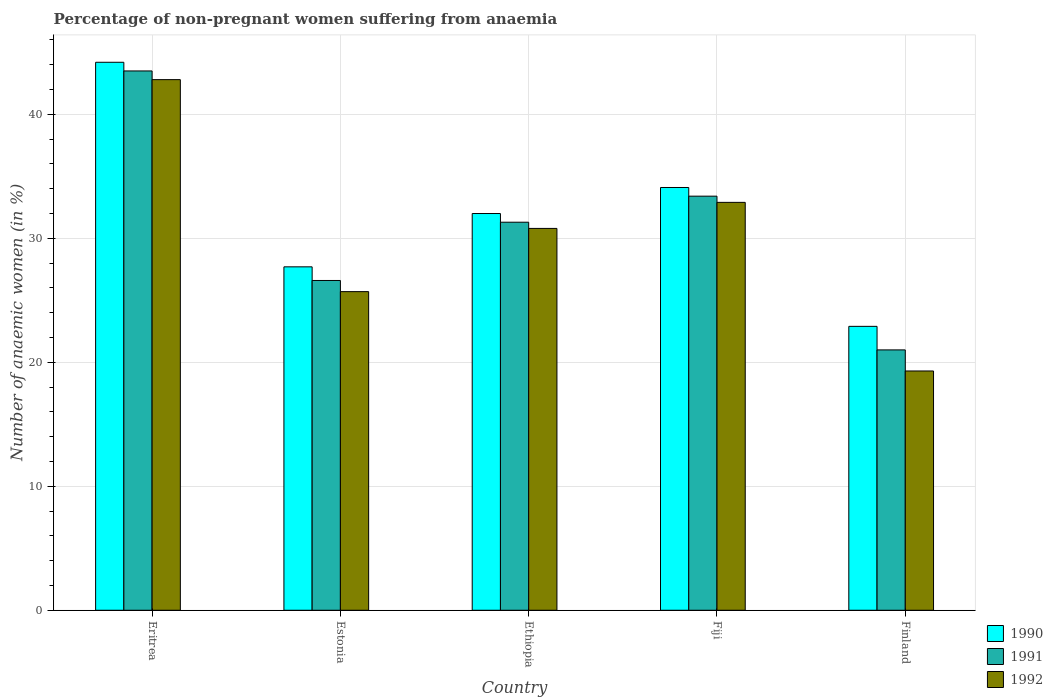How many groups of bars are there?
Your answer should be compact. 5. Are the number of bars per tick equal to the number of legend labels?
Offer a terse response. Yes. How many bars are there on the 3rd tick from the right?
Provide a short and direct response. 3. In how many cases, is the number of bars for a given country not equal to the number of legend labels?
Make the answer very short. 0. What is the percentage of non-pregnant women suffering from anaemia in 1991 in Eritrea?
Keep it short and to the point. 43.5. Across all countries, what is the maximum percentage of non-pregnant women suffering from anaemia in 1990?
Your answer should be very brief. 44.2. In which country was the percentage of non-pregnant women suffering from anaemia in 1992 maximum?
Provide a short and direct response. Eritrea. In which country was the percentage of non-pregnant women suffering from anaemia in 1990 minimum?
Your response must be concise. Finland. What is the total percentage of non-pregnant women suffering from anaemia in 1992 in the graph?
Make the answer very short. 151.5. What is the difference between the percentage of non-pregnant women suffering from anaemia in 1991 in Fiji and that in Finland?
Offer a terse response. 12.4. What is the difference between the percentage of non-pregnant women suffering from anaemia in 1991 in Ethiopia and the percentage of non-pregnant women suffering from anaemia in 1990 in Eritrea?
Give a very brief answer. -12.9. What is the average percentage of non-pregnant women suffering from anaemia in 1990 per country?
Your answer should be compact. 32.18. What is the difference between the percentage of non-pregnant women suffering from anaemia of/in 1992 and percentage of non-pregnant women suffering from anaemia of/in 1991 in Estonia?
Provide a succinct answer. -0.9. In how many countries, is the percentage of non-pregnant women suffering from anaemia in 1991 greater than 40 %?
Give a very brief answer. 1. What is the ratio of the percentage of non-pregnant women suffering from anaemia in 1991 in Eritrea to that in Finland?
Provide a short and direct response. 2.07. What is the difference between the highest and the second highest percentage of non-pregnant women suffering from anaemia in 1990?
Your answer should be compact. -2.1. In how many countries, is the percentage of non-pregnant women suffering from anaemia in 1990 greater than the average percentage of non-pregnant women suffering from anaemia in 1990 taken over all countries?
Offer a terse response. 2. What does the 2nd bar from the right in Estonia represents?
Provide a succinct answer. 1991. Are all the bars in the graph horizontal?
Ensure brevity in your answer.  No. How many countries are there in the graph?
Give a very brief answer. 5. What is the difference between two consecutive major ticks on the Y-axis?
Ensure brevity in your answer.  10. Does the graph contain grids?
Give a very brief answer. Yes. How many legend labels are there?
Make the answer very short. 3. How are the legend labels stacked?
Give a very brief answer. Vertical. What is the title of the graph?
Offer a terse response. Percentage of non-pregnant women suffering from anaemia. What is the label or title of the X-axis?
Provide a succinct answer. Country. What is the label or title of the Y-axis?
Provide a short and direct response. Number of anaemic women (in %). What is the Number of anaemic women (in %) in 1990 in Eritrea?
Provide a succinct answer. 44.2. What is the Number of anaemic women (in %) in 1991 in Eritrea?
Provide a short and direct response. 43.5. What is the Number of anaemic women (in %) in 1992 in Eritrea?
Make the answer very short. 42.8. What is the Number of anaemic women (in %) of 1990 in Estonia?
Offer a very short reply. 27.7. What is the Number of anaemic women (in %) in 1991 in Estonia?
Make the answer very short. 26.6. What is the Number of anaemic women (in %) of 1992 in Estonia?
Ensure brevity in your answer.  25.7. What is the Number of anaemic women (in %) of 1990 in Ethiopia?
Your answer should be compact. 32. What is the Number of anaemic women (in %) in 1991 in Ethiopia?
Your answer should be compact. 31.3. What is the Number of anaemic women (in %) of 1992 in Ethiopia?
Ensure brevity in your answer.  30.8. What is the Number of anaemic women (in %) in 1990 in Fiji?
Make the answer very short. 34.1. What is the Number of anaemic women (in %) in 1991 in Fiji?
Your answer should be compact. 33.4. What is the Number of anaemic women (in %) in 1992 in Fiji?
Your answer should be compact. 32.9. What is the Number of anaemic women (in %) of 1990 in Finland?
Offer a terse response. 22.9. What is the Number of anaemic women (in %) in 1991 in Finland?
Provide a succinct answer. 21. What is the Number of anaemic women (in %) of 1992 in Finland?
Give a very brief answer. 19.3. Across all countries, what is the maximum Number of anaemic women (in %) of 1990?
Offer a very short reply. 44.2. Across all countries, what is the maximum Number of anaemic women (in %) in 1991?
Provide a short and direct response. 43.5. Across all countries, what is the maximum Number of anaemic women (in %) of 1992?
Ensure brevity in your answer.  42.8. Across all countries, what is the minimum Number of anaemic women (in %) of 1990?
Make the answer very short. 22.9. Across all countries, what is the minimum Number of anaemic women (in %) in 1991?
Your answer should be compact. 21. Across all countries, what is the minimum Number of anaemic women (in %) of 1992?
Your answer should be very brief. 19.3. What is the total Number of anaemic women (in %) of 1990 in the graph?
Keep it short and to the point. 160.9. What is the total Number of anaemic women (in %) of 1991 in the graph?
Give a very brief answer. 155.8. What is the total Number of anaemic women (in %) in 1992 in the graph?
Offer a very short reply. 151.5. What is the difference between the Number of anaemic women (in %) of 1990 in Eritrea and that in Estonia?
Offer a very short reply. 16.5. What is the difference between the Number of anaemic women (in %) in 1992 in Eritrea and that in Estonia?
Give a very brief answer. 17.1. What is the difference between the Number of anaemic women (in %) of 1991 in Eritrea and that in Ethiopia?
Make the answer very short. 12.2. What is the difference between the Number of anaemic women (in %) of 1990 in Eritrea and that in Fiji?
Your answer should be compact. 10.1. What is the difference between the Number of anaemic women (in %) of 1991 in Eritrea and that in Fiji?
Provide a succinct answer. 10.1. What is the difference between the Number of anaemic women (in %) in 1992 in Eritrea and that in Fiji?
Keep it short and to the point. 9.9. What is the difference between the Number of anaemic women (in %) of 1990 in Eritrea and that in Finland?
Your answer should be very brief. 21.3. What is the difference between the Number of anaemic women (in %) of 1992 in Eritrea and that in Finland?
Your response must be concise. 23.5. What is the difference between the Number of anaemic women (in %) in 1990 in Estonia and that in Ethiopia?
Offer a terse response. -4.3. What is the difference between the Number of anaemic women (in %) in 1991 in Estonia and that in Ethiopia?
Give a very brief answer. -4.7. What is the difference between the Number of anaemic women (in %) in 1991 in Estonia and that in Fiji?
Provide a succinct answer. -6.8. What is the difference between the Number of anaemic women (in %) in 1991 in Ethiopia and that in Fiji?
Provide a short and direct response. -2.1. What is the difference between the Number of anaemic women (in %) of 1992 in Ethiopia and that in Fiji?
Offer a very short reply. -2.1. What is the difference between the Number of anaemic women (in %) in 1991 in Ethiopia and that in Finland?
Your answer should be compact. 10.3. What is the difference between the Number of anaemic women (in %) of 1992 in Ethiopia and that in Finland?
Provide a succinct answer. 11.5. What is the difference between the Number of anaemic women (in %) of 1992 in Fiji and that in Finland?
Offer a terse response. 13.6. What is the difference between the Number of anaemic women (in %) in 1990 in Eritrea and the Number of anaemic women (in %) in 1991 in Ethiopia?
Your answer should be compact. 12.9. What is the difference between the Number of anaemic women (in %) in 1990 in Eritrea and the Number of anaemic women (in %) in 1992 in Ethiopia?
Make the answer very short. 13.4. What is the difference between the Number of anaemic women (in %) of 1990 in Eritrea and the Number of anaemic women (in %) of 1991 in Fiji?
Provide a short and direct response. 10.8. What is the difference between the Number of anaemic women (in %) of 1990 in Eritrea and the Number of anaemic women (in %) of 1991 in Finland?
Your response must be concise. 23.2. What is the difference between the Number of anaemic women (in %) in 1990 in Eritrea and the Number of anaemic women (in %) in 1992 in Finland?
Ensure brevity in your answer.  24.9. What is the difference between the Number of anaemic women (in %) of 1991 in Eritrea and the Number of anaemic women (in %) of 1992 in Finland?
Give a very brief answer. 24.2. What is the difference between the Number of anaemic women (in %) of 1990 in Estonia and the Number of anaemic women (in %) of 1992 in Ethiopia?
Make the answer very short. -3.1. What is the difference between the Number of anaemic women (in %) of 1991 in Estonia and the Number of anaemic women (in %) of 1992 in Ethiopia?
Provide a short and direct response. -4.2. What is the difference between the Number of anaemic women (in %) in 1991 in Estonia and the Number of anaemic women (in %) in 1992 in Fiji?
Give a very brief answer. -6.3. What is the difference between the Number of anaemic women (in %) of 1990 in Estonia and the Number of anaemic women (in %) of 1991 in Finland?
Keep it short and to the point. 6.7. What is the difference between the Number of anaemic women (in %) of 1990 in Ethiopia and the Number of anaemic women (in %) of 1992 in Fiji?
Offer a very short reply. -0.9. What is the difference between the Number of anaemic women (in %) in 1991 in Ethiopia and the Number of anaemic women (in %) in 1992 in Fiji?
Keep it short and to the point. -1.6. What is the difference between the Number of anaemic women (in %) of 1990 in Ethiopia and the Number of anaemic women (in %) of 1992 in Finland?
Ensure brevity in your answer.  12.7. What is the difference between the Number of anaemic women (in %) in 1991 in Ethiopia and the Number of anaemic women (in %) in 1992 in Finland?
Your response must be concise. 12. What is the difference between the Number of anaemic women (in %) of 1990 in Fiji and the Number of anaemic women (in %) of 1991 in Finland?
Offer a very short reply. 13.1. What is the difference between the Number of anaemic women (in %) in 1990 in Fiji and the Number of anaemic women (in %) in 1992 in Finland?
Your answer should be very brief. 14.8. What is the difference between the Number of anaemic women (in %) of 1991 in Fiji and the Number of anaemic women (in %) of 1992 in Finland?
Make the answer very short. 14.1. What is the average Number of anaemic women (in %) in 1990 per country?
Your answer should be very brief. 32.18. What is the average Number of anaemic women (in %) of 1991 per country?
Ensure brevity in your answer.  31.16. What is the average Number of anaemic women (in %) in 1992 per country?
Make the answer very short. 30.3. What is the difference between the Number of anaemic women (in %) in 1990 and Number of anaemic women (in %) in 1991 in Eritrea?
Provide a short and direct response. 0.7. What is the difference between the Number of anaemic women (in %) in 1990 and Number of anaemic women (in %) in 1992 in Eritrea?
Make the answer very short. 1.4. What is the difference between the Number of anaemic women (in %) in 1991 and Number of anaemic women (in %) in 1992 in Estonia?
Keep it short and to the point. 0.9. What is the difference between the Number of anaemic women (in %) in 1990 and Number of anaemic women (in %) in 1992 in Ethiopia?
Make the answer very short. 1.2. What is the difference between the Number of anaemic women (in %) of 1991 and Number of anaemic women (in %) of 1992 in Ethiopia?
Your answer should be compact. 0.5. What is the difference between the Number of anaemic women (in %) in 1990 and Number of anaemic women (in %) in 1991 in Fiji?
Your response must be concise. 0.7. What is the difference between the Number of anaemic women (in %) of 1990 and Number of anaemic women (in %) of 1992 in Fiji?
Your answer should be very brief. 1.2. What is the difference between the Number of anaemic women (in %) of 1991 and Number of anaemic women (in %) of 1992 in Fiji?
Your response must be concise. 0.5. What is the ratio of the Number of anaemic women (in %) in 1990 in Eritrea to that in Estonia?
Your answer should be compact. 1.6. What is the ratio of the Number of anaemic women (in %) in 1991 in Eritrea to that in Estonia?
Make the answer very short. 1.64. What is the ratio of the Number of anaemic women (in %) in 1992 in Eritrea to that in Estonia?
Keep it short and to the point. 1.67. What is the ratio of the Number of anaemic women (in %) in 1990 in Eritrea to that in Ethiopia?
Offer a very short reply. 1.38. What is the ratio of the Number of anaemic women (in %) of 1991 in Eritrea to that in Ethiopia?
Your response must be concise. 1.39. What is the ratio of the Number of anaemic women (in %) in 1992 in Eritrea to that in Ethiopia?
Your response must be concise. 1.39. What is the ratio of the Number of anaemic women (in %) in 1990 in Eritrea to that in Fiji?
Make the answer very short. 1.3. What is the ratio of the Number of anaemic women (in %) of 1991 in Eritrea to that in Fiji?
Your response must be concise. 1.3. What is the ratio of the Number of anaemic women (in %) of 1992 in Eritrea to that in Fiji?
Offer a terse response. 1.3. What is the ratio of the Number of anaemic women (in %) in 1990 in Eritrea to that in Finland?
Make the answer very short. 1.93. What is the ratio of the Number of anaemic women (in %) in 1991 in Eritrea to that in Finland?
Your answer should be very brief. 2.07. What is the ratio of the Number of anaemic women (in %) in 1992 in Eritrea to that in Finland?
Give a very brief answer. 2.22. What is the ratio of the Number of anaemic women (in %) in 1990 in Estonia to that in Ethiopia?
Offer a very short reply. 0.87. What is the ratio of the Number of anaemic women (in %) in 1991 in Estonia to that in Ethiopia?
Offer a terse response. 0.85. What is the ratio of the Number of anaemic women (in %) in 1992 in Estonia to that in Ethiopia?
Provide a succinct answer. 0.83. What is the ratio of the Number of anaemic women (in %) in 1990 in Estonia to that in Fiji?
Provide a short and direct response. 0.81. What is the ratio of the Number of anaemic women (in %) in 1991 in Estonia to that in Fiji?
Offer a very short reply. 0.8. What is the ratio of the Number of anaemic women (in %) of 1992 in Estonia to that in Fiji?
Your response must be concise. 0.78. What is the ratio of the Number of anaemic women (in %) of 1990 in Estonia to that in Finland?
Offer a very short reply. 1.21. What is the ratio of the Number of anaemic women (in %) of 1991 in Estonia to that in Finland?
Offer a terse response. 1.27. What is the ratio of the Number of anaemic women (in %) of 1992 in Estonia to that in Finland?
Your answer should be very brief. 1.33. What is the ratio of the Number of anaemic women (in %) in 1990 in Ethiopia to that in Fiji?
Keep it short and to the point. 0.94. What is the ratio of the Number of anaemic women (in %) in 1991 in Ethiopia to that in Fiji?
Your response must be concise. 0.94. What is the ratio of the Number of anaemic women (in %) of 1992 in Ethiopia to that in Fiji?
Give a very brief answer. 0.94. What is the ratio of the Number of anaemic women (in %) of 1990 in Ethiopia to that in Finland?
Your response must be concise. 1.4. What is the ratio of the Number of anaemic women (in %) in 1991 in Ethiopia to that in Finland?
Ensure brevity in your answer.  1.49. What is the ratio of the Number of anaemic women (in %) of 1992 in Ethiopia to that in Finland?
Your response must be concise. 1.6. What is the ratio of the Number of anaemic women (in %) in 1990 in Fiji to that in Finland?
Make the answer very short. 1.49. What is the ratio of the Number of anaemic women (in %) of 1991 in Fiji to that in Finland?
Give a very brief answer. 1.59. What is the ratio of the Number of anaemic women (in %) of 1992 in Fiji to that in Finland?
Your answer should be compact. 1.7. What is the difference between the highest and the second highest Number of anaemic women (in %) of 1991?
Make the answer very short. 10.1. What is the difference between the highest and the second highest Number of anaemic women (in %) of 1992?
Offer a very short reply. 9.9. What is the difference between the highest and the lowest Number of anaemic women (in %) in 1990?
Your response must be concise. 21.3. What is the difference between the highest and the lowest Number of anaemic women (in %) in 1992?
Offer a very short reply. 23.5. 